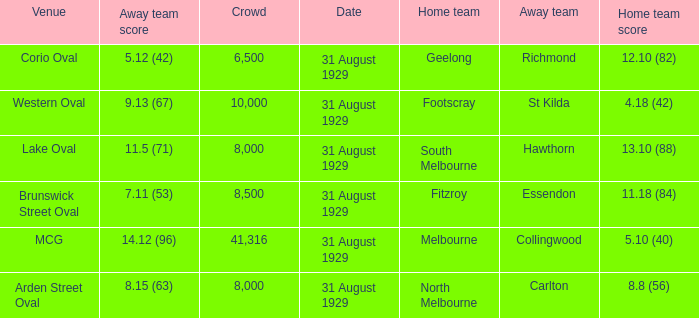What was the score of the home team when the away team scored 14.12 (96)? 5.10 (40). 